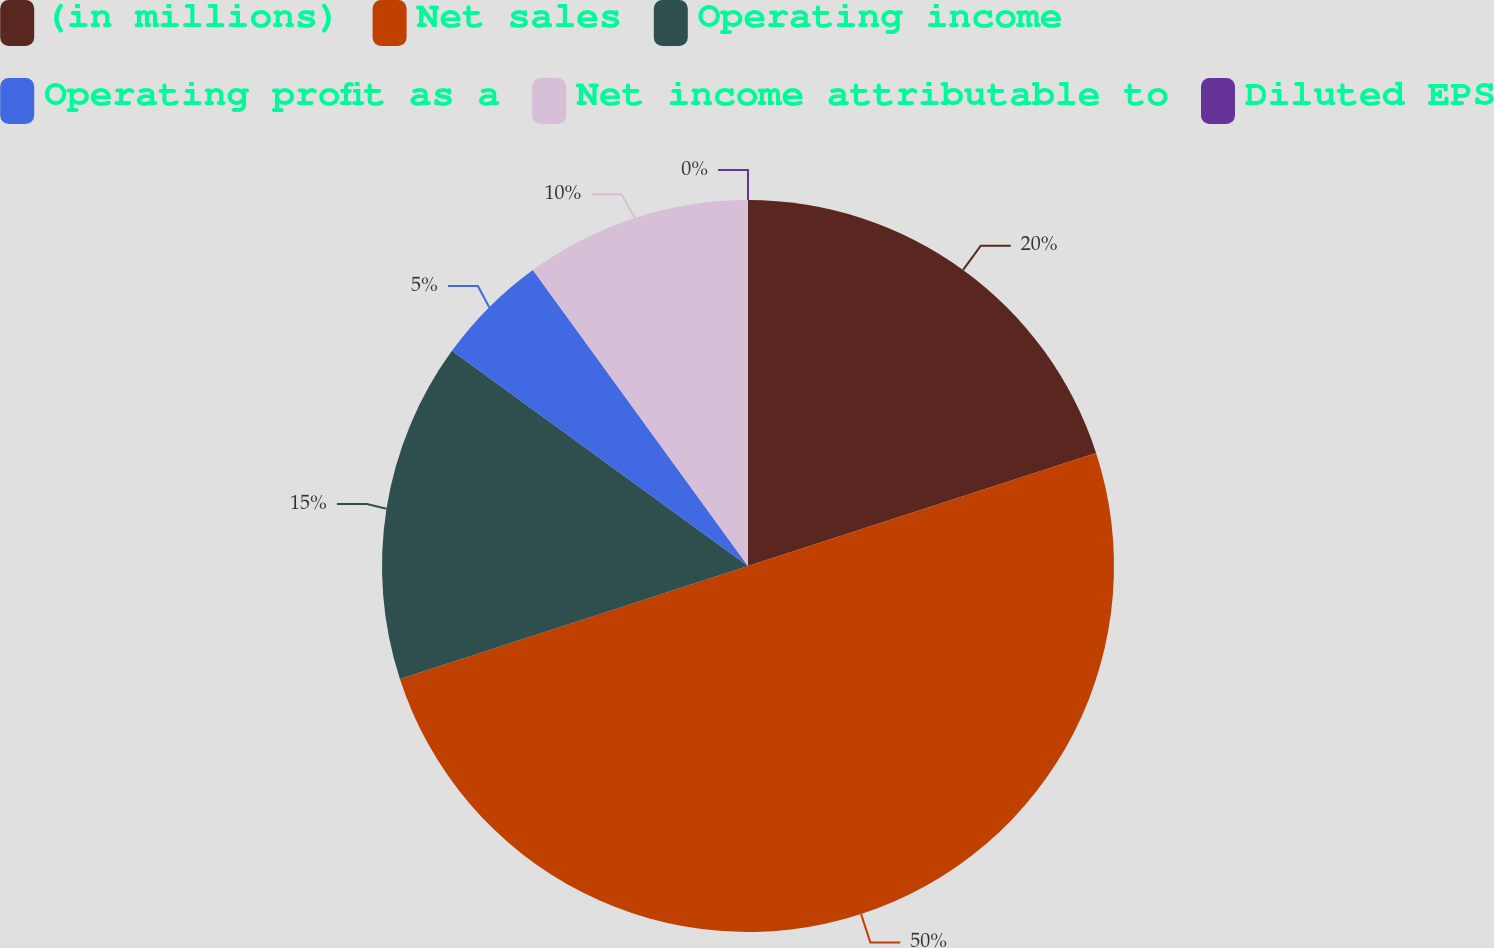<chart> <loc_0><loc_0><loc_500><loc_500><pie_chart><fcel>(in millions)<fcel>Net sales<fcel>Operating income<fcel>Operating profit as a<fcel>Net income attributable to<fcel>Diluted EPS<nl><fcel>20.0%<fcel>50.0%<fcel>15.0%<fcel>5.0%<fcel>10.0%<fcel>0.0%<nl></chart> 